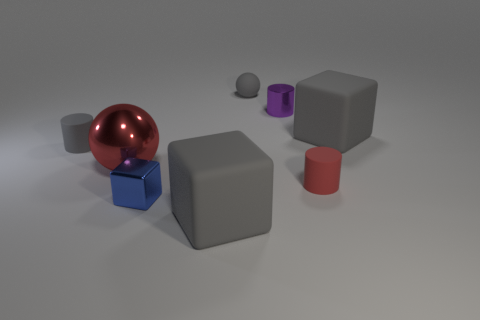What color is the big rubber object that is behind the big gray rubber block that is to the left of the gray cube that is behind the metal sphere?
Provide a succinct answer. Gray. The large metallic sphere has what color?
Provide a short and direct response. Red. Are there more big gray blocks to the left of the matte sphere than red metal things that are on the right side of the blue object?
Offer a very short reply. Yes. There is a small red thing; is its shape the same as the purple metal thing right of the red metallic object?
Provide a short and direct response. Yes. There is a ball that is in front of the gray matte cylinder; is its size the same as the gray matte cube that is in front of the small red cylinder?
Your response must be concise. Yes. Is there a matte thing that is behind the big shiny sphere that is in front of the big rubber cube right of the tiny rubber sphere?
Offer a terse response. Yes. Is the number of small blue objects behind the red cylinder less than the number of gray matte cubes that are behind the big red ball?
Provide a short and direct response. Yes. There is a large object that is the same material as the tiny blue cube; what shape is it?
Ensure brevity in your answer.  Sphere. What is the size of the matte object to the left of the big rubber thing that is in front of the gray matte block that is behind the red shiny sphere?
Make the answer very short. Small. Are there more large rubber objects than tiny red metal things?
Your response must be concise. Yes. 